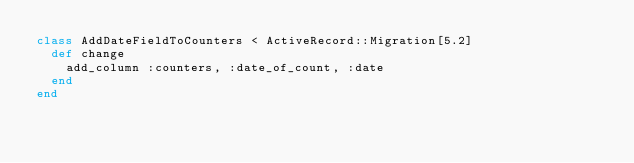Convert code to text. <code><loc_0><loc_0><loc_500><loc_500><_Ruby_>class AddDateFieldToCounters < ActiveRecord::Migration[5.2]
  def change
    add_column :counters, :date_of_count, :date
  end
end
</code> 